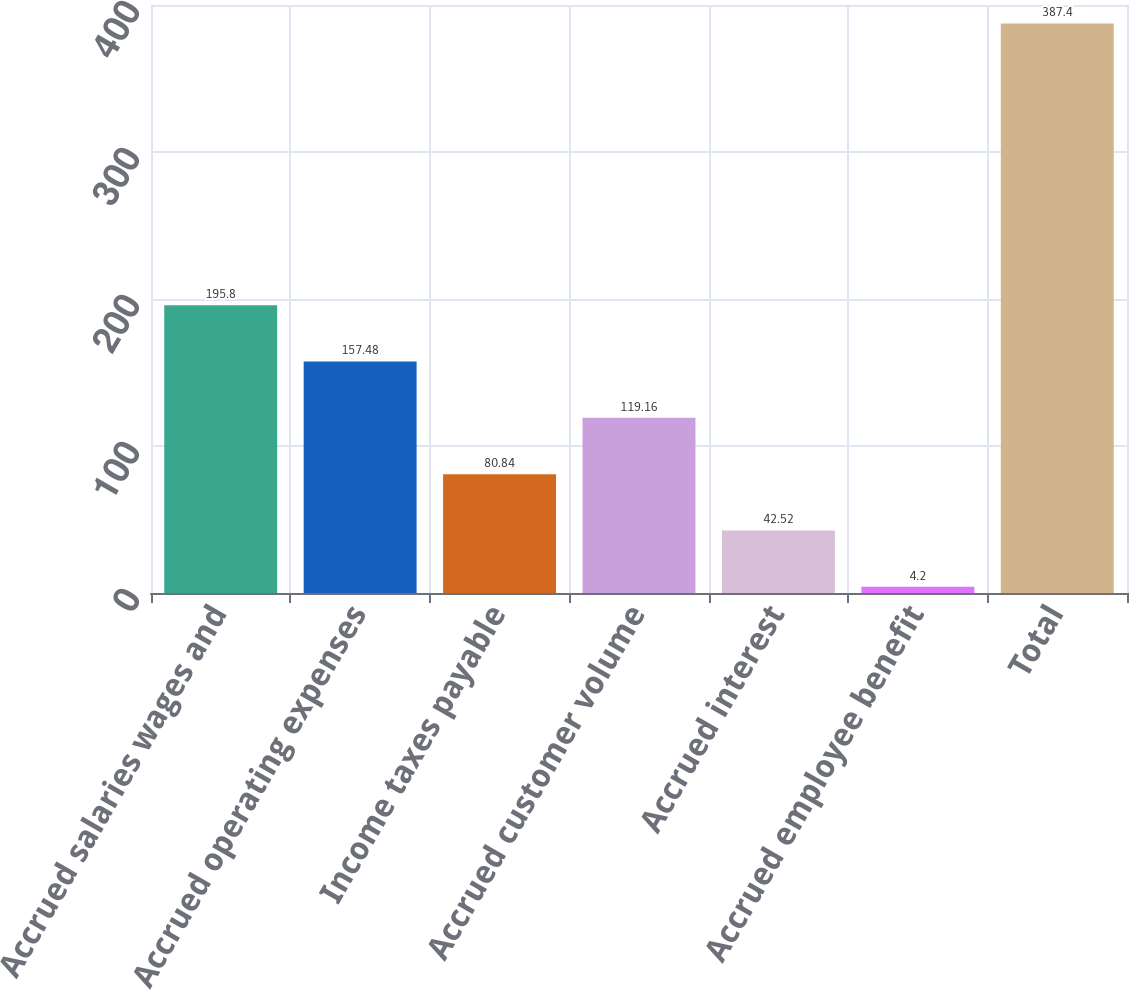Convert chart. <chart><loc_0><loc_0><loc_500><loc_500><bar_chart><fcel>Accrued salaries wages and<fcel>Accrued operating expenses<fcel>Income taxes payable<fcel>Accrued customer volume<fcel>Accrued interest<fcel>Accrued employee benefit<fcel>Total<nl><fcel>195.8<fcel>157.48<fcel>80.84<fcel>119.16<fcel>42.52<fcel>4.2<fcel>387.4<nl></chart> 